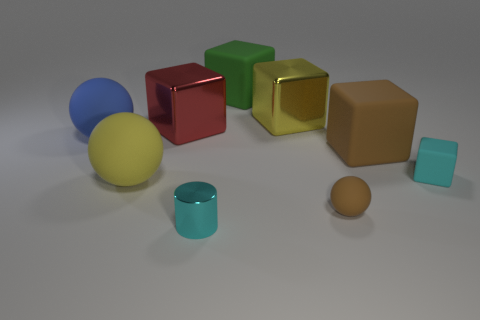Subtract all tiny matte blocks. How many blocks are left? 4 Subtract all yellow balls. How many balls are left? 2 Subtract all cylinders. How many objects are left? 8 Subtract 1 balls. How many balls are left? 2 Add 5 large red metallic blocks. How many large red metallic blocks are left? 6 Add 9 big purple matte spheres. How many big purple matte spheres exist? 9 Subtract 0 yellow cylinders. How many objects are left? 9 Subtract all red spheres. Subtract all purple cubes. How many spheres are left? 3 Subtract all yellow spheres. How many yellow cylinders are left? 0 Subtract all cyan rubber cubes. Subtract all big matte spheres. How many objects are left? 6 